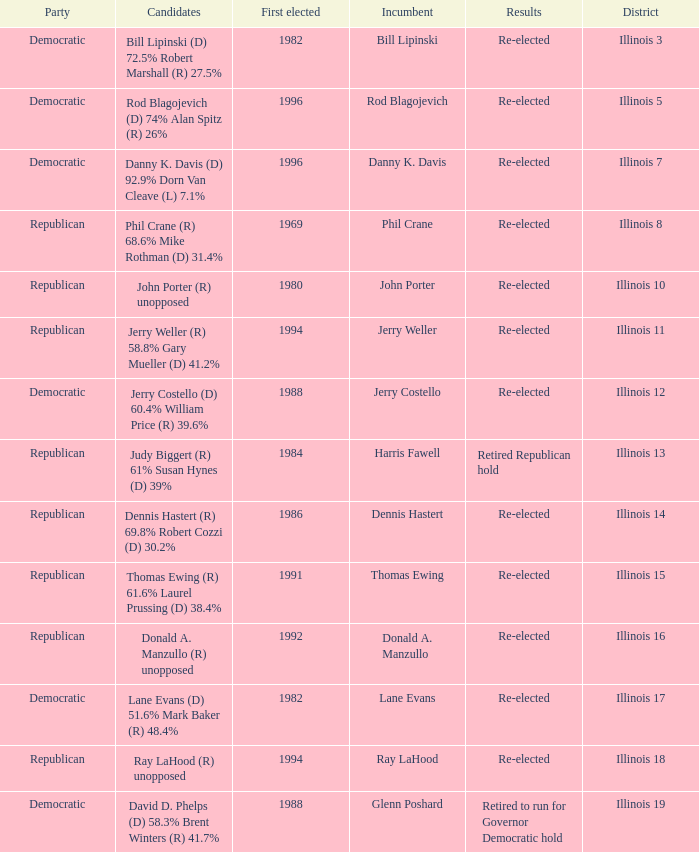What was the result in Illinois 7? Re-elected. 